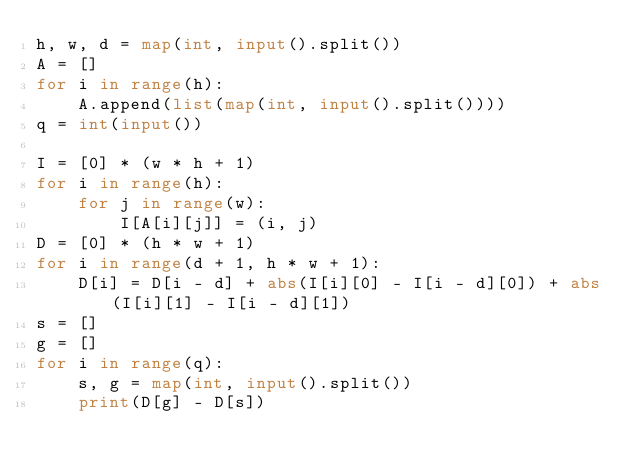<code> <loc_0><loc_0><loc_500><loc_500><_Python_>h, w, d = map(int, input().split())
A = []
for i in range(h):
    A.append(list(map(int, input().split())))
q = int(input())

I = [0] * (w * h + 1)
for i in range(h):
    for j in range(w):
        I[A[i][j]] = (i, j)
D = [0] * (h * w + 1)
for i in range(d + 1, h * w + 1):
    D[i] = D[i - d] + abs(I[i][0] - I[i - d][0]) + abs(I[i][1] - I[i - d][1])
s = []
g = []
for i in range(q):
    s, g = map(int, input().split())
    print(D[g] - D[s])
</code> 